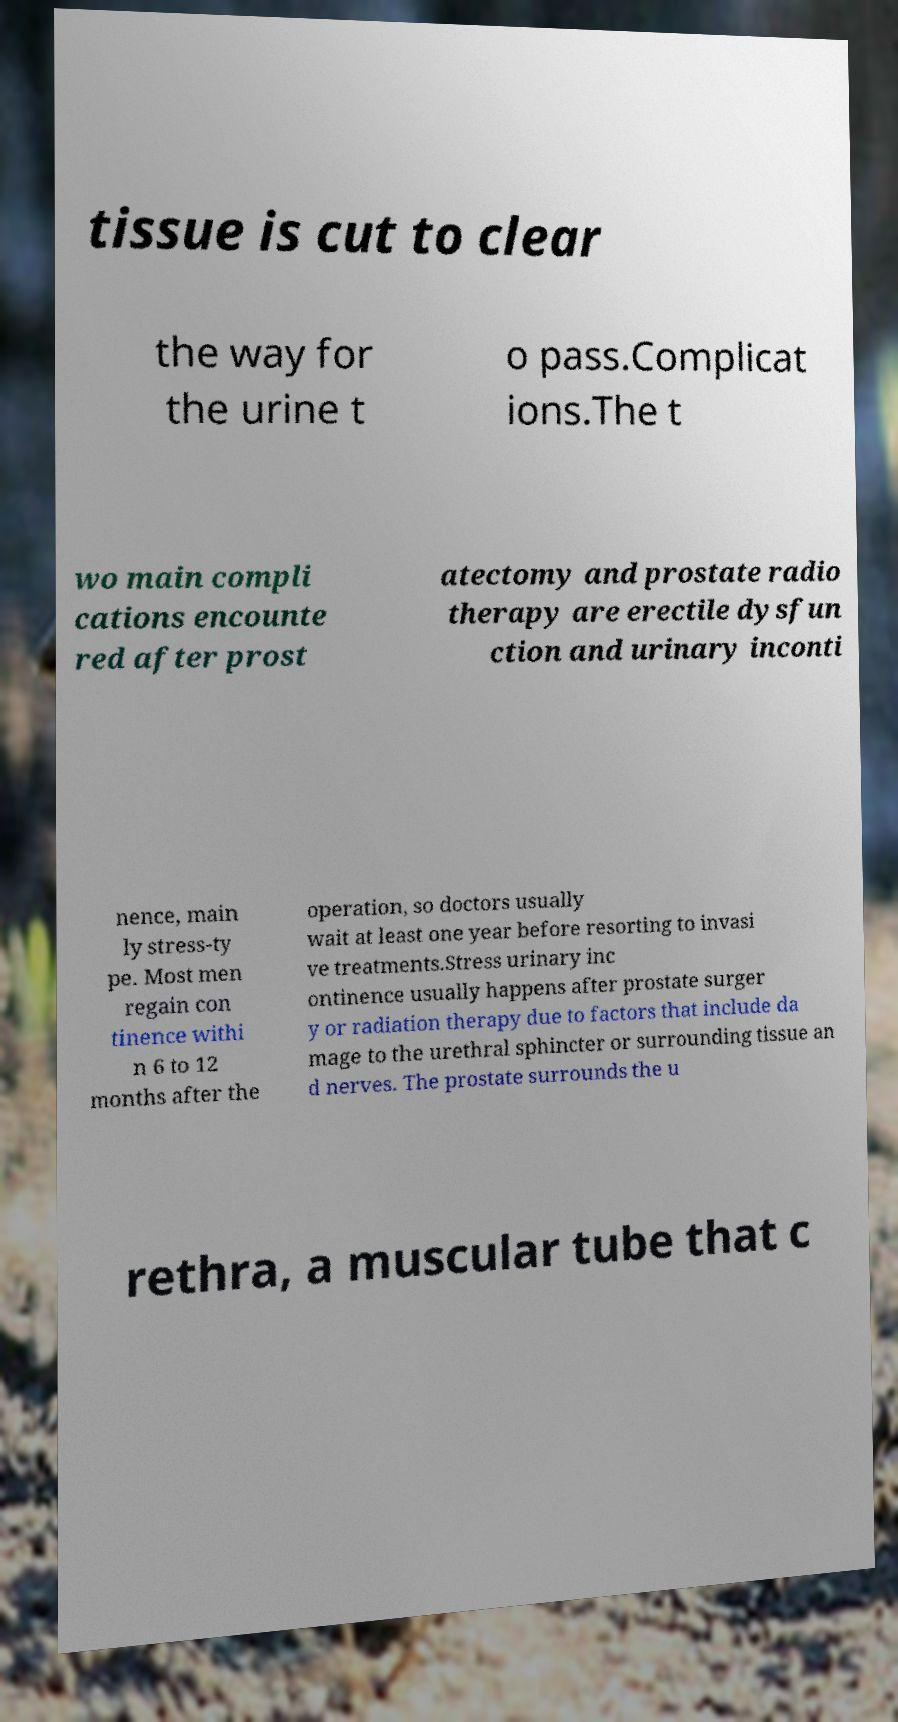Could you extract and type out the text from this image? tissue is cut to clear the way for the urine t o pass.Complicat ions.The t wo main compli cations encounte red after prost atectomy and prostate radio therapy are erectile dysfun ction and urinary inconti nence, main ly stress-ty pe. Most men regain con tinence withi n 6 to 12 months after the operation, so doctors usually wait at least one year before resorting to invasi ve treatments.Stress urinary inc ontinence usually happens after prostate surger y or radiation therapy due to factors that include da mage to the urethral sphincter or surrounding tissue an d nerves. The prostate surrounds the u rethra, a muscular tube that c 